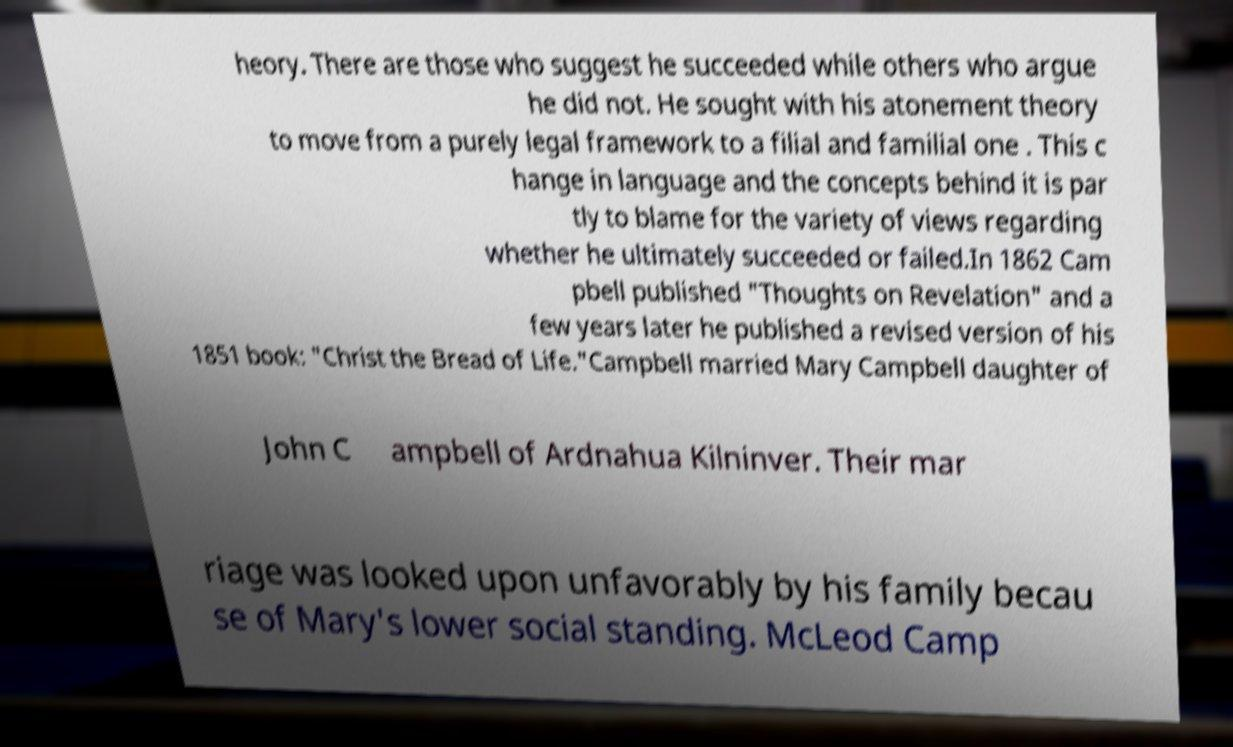Please read and relay the text visible in this image. What does it say? heory. There are those who suggest he succeeded while others who argue he did not. He sought with his atonement theory to move from a purely legal framework to a filial and familial one . This c hange in language and the concepts behind it is par tly to blame for the variety of views regarding whether he ultimately succeeded or failed.In 1862 Cam pbell published "Thoughts on Revelation" and a few years later he published a revised version of his 1851 book: "Christ the Bread of Life."Campbell married Mary Campbell daughter of John C ampbell of Ardnahua Kilninver. Their mar riage was looked upon unfavorably by his family becau se of Mary's lower social standing. McLeod Camp 